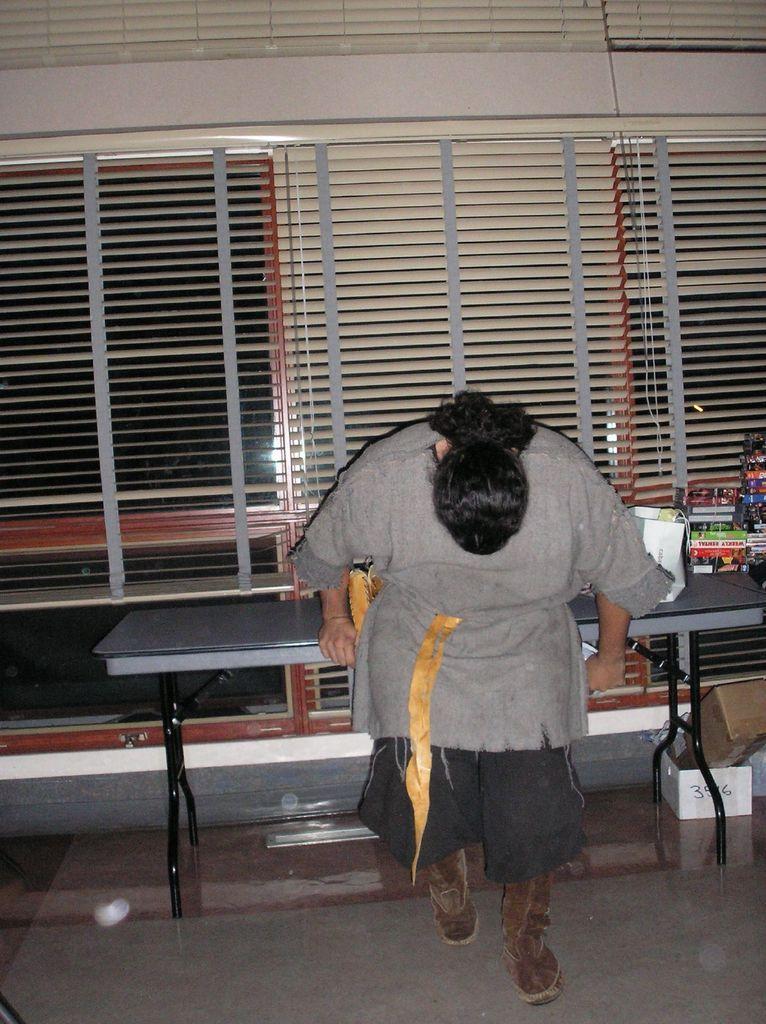Could you give a brief overview of what you see in this image? The picture is taken inside a room. There is a person and work books and is looking down. There is table to the wall and some things are placed on it. There is a cardboard box below the table and a number is written on it. In the background there are windows and window blinds to it.  